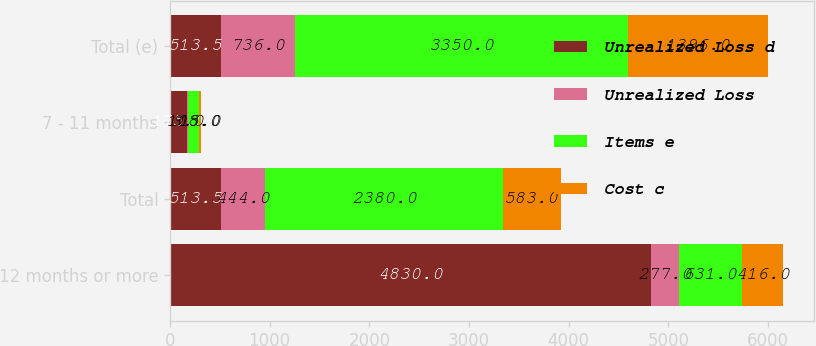Convert chart to OTSL. <chart><loc_0><loc_0><loc_500><loc_500><stacked_bar_chart><ecel><fcel>12 months or more<fcel>Total<fcel>7 - 11 months<fcel>Total (e)<nl><fcel>Unrealized Loss d<fcel>4830<fcel>513.5<fcel>175<fcel>513.5<nl><fcel>Unrealized Loss<fcel>277<fcel>444<fcel>9<fcel>736<nl><fcel>Items e<fcel>631<fcel>2380<fcel>108<fcel>3350<nl><fcel>Cost c<fcel>416<fcel>583<fcel>15<fcel>1396<nl></chart> 